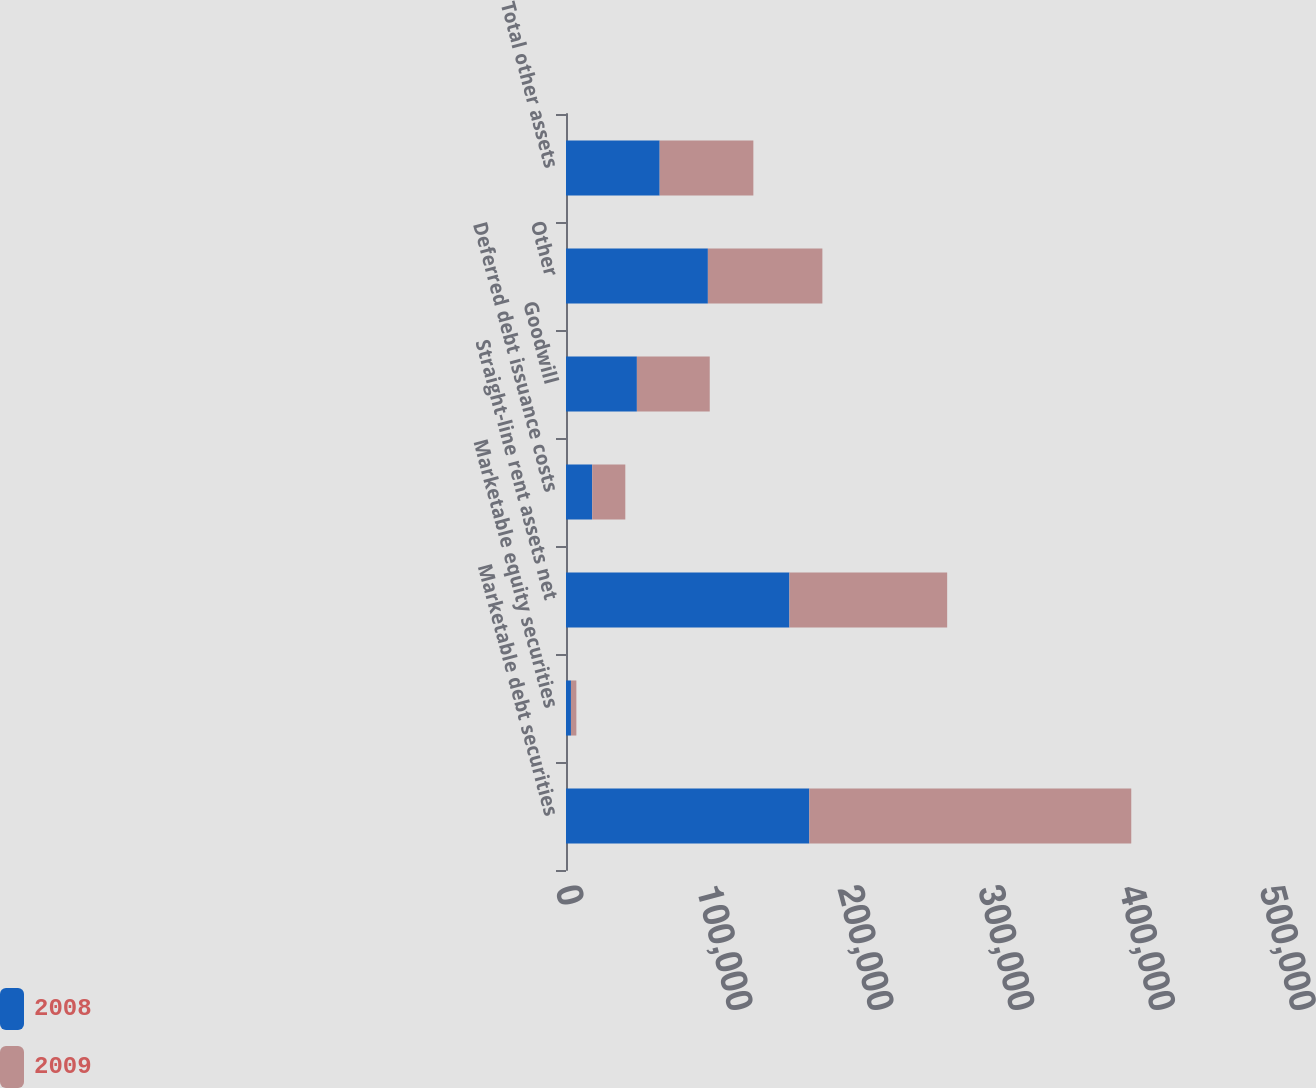<chart> <loc_0><loc_0><loc_500><loc_500><stacked_bar_chart><ecel><fcel>Marketable debt securities<fcel>Marketable equity securities<fcel>Straight-line rent assets net<fcel>Deferred debt issuance costs<fcel>Goodwill<fcel>Other<fcel>Total other assets<nl><fcel>2008<fcel>172799<fcel>3521<fcel>158674<fcel>18607<fcel>50346<fcel>100767<fcel>66533<nl><fcel>2009<fcel>228660<fcel>3845<fcel>112038<fcel>23512<fcel>51746<fcel>81320<fcel>66533<nl></chart> 